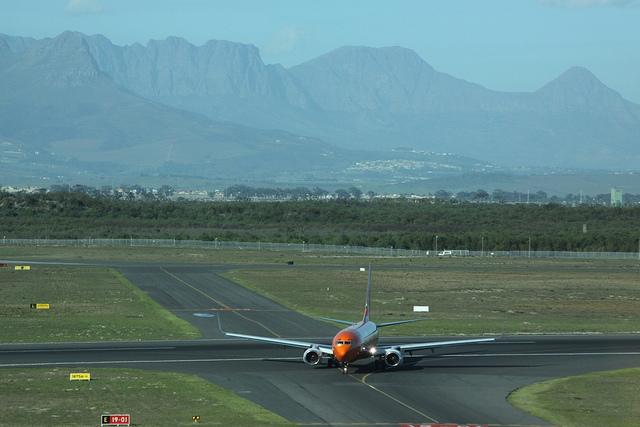What action is this plane making?
Give a very brief answer. Taxiing. How many engines does the plane have?
Give a very brief answer. 2. How many airplanes with light blue paint are visible in this photograph?
Keep it brief. 0. Is this Antarctica?
Give a very brief answer. No. 